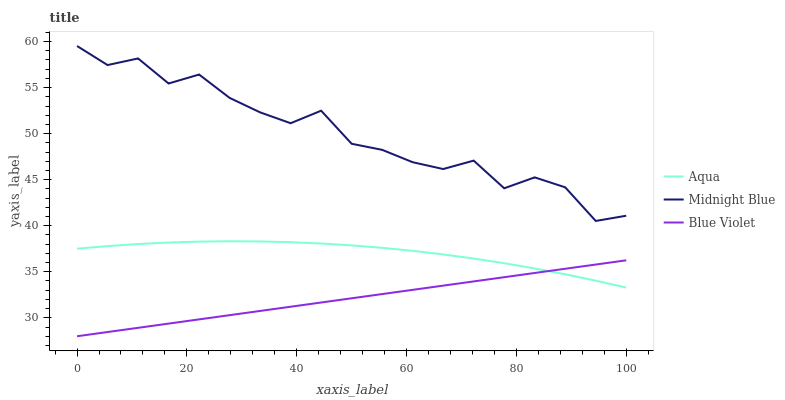Does Blue Violet have the minimum area under the curve?
Answer yes or no. Yes. Does Midnight Blue have the maximum area under the curve?
Answer yes or no. Yes. Does Midnight Blue have the minimum area under the curve?
Answer yes or no. No. Does Blue Violet have the maximum area under the curve?
Answer yes or no. No. Is Blue Violet the smoothest?
Answer yes or no. Yes. Is Midnight Blue the roughest?
Answer yes or no. Yes. Is Midnight Blue the smoothest?
Answer yes or no. No. Is Blue Violet the roughest?
Answer yes or no. No. Does Blue Violet have the lowest value?
Answer yes or no. Yes. Does Midnight Blue have the lowest value?
Answer yes or no. No. Does Midnight Blue have the highest value?
Answer yes or no. Yes. Does Blue Violet have the highest value?
Answer yes or no. No. Is Blue Violet less than Midnight Blue?
Answer yes or no. Yes. Is Midnight Blue greater than Aqua?
Answer yes or no. Yes. Does Blue Violet intersect Aqua?
Answer yes or no. Yes. Is Blue Violet less than Aqua?
Answer yes or no. No. Is Blue Violet greater than Aqua?
Answer yes or no. No. Does Blue Violet intersect Midnight Blue?
Answer yes or no. No. 